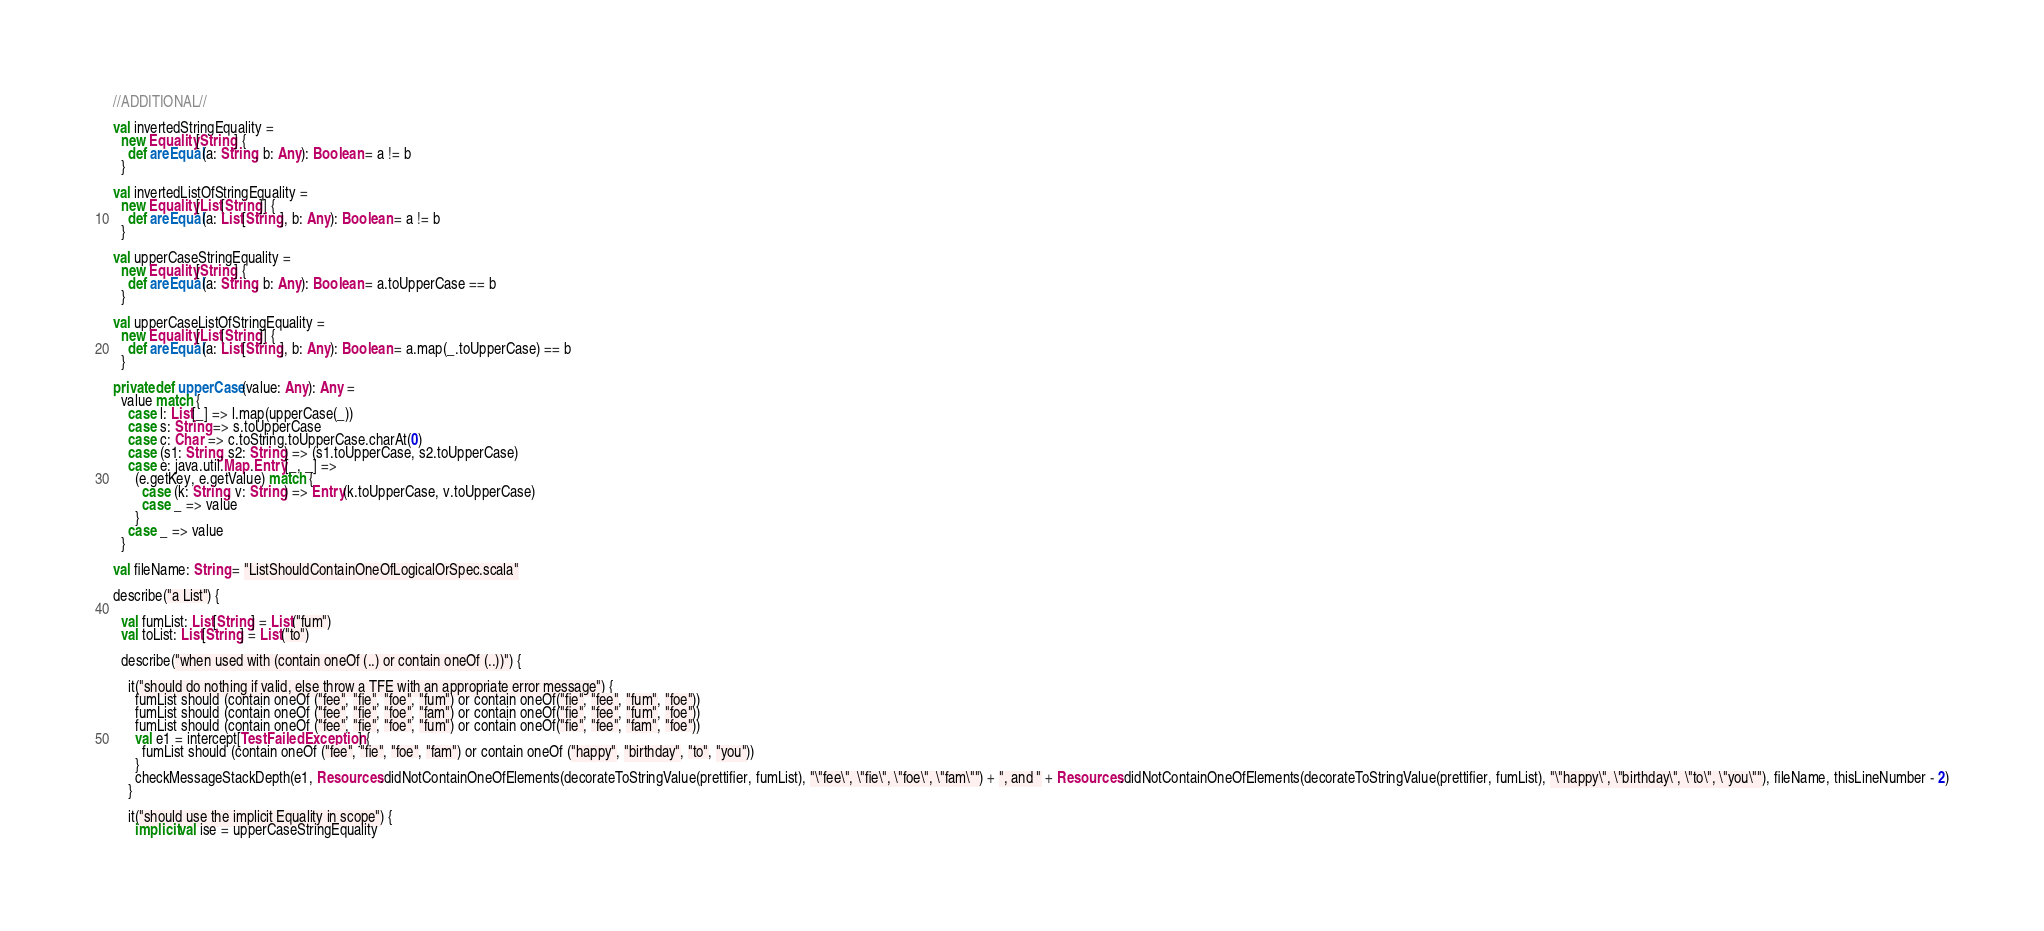<code> <loc_0><loc_0><loc_500><loc_500><_Scala_>  //ADDITIONAL//

  val invertedStringEquality =
    new Equality[String] {
      def areEqual(a: String, b: Any): Boolean = a != b
    }

  val invertedListOfStringEquality =
    new Equality[List[String]] {
      def areEqual(a: List[String], b: Any): Boolean = a != b
    }

  val upperCaseStringEquality =
    new Equality[String] {
      def areEqual(a: String, b: Any): Boolean = a.toUpperCase == b
    }

  val upperCaseListOfStringEquality =
    new Equality[List[String]] {
      def areEqual(a: List[String], b: Any): Boolean = a.map(_.toUpperCase) == b
    }

  private def upperCase(value: Any): Any =
    value match {
      case l: List[_] => l.map(upperCase(_))
      case s: String => s.toUpperCase
      case c: Char => c.toString.toUpperCase.charAt(0)
      case (s1: String, s2: String) => (s1.toUpperCase, s2.toUpperCase)
      case e: java.util.Map.Entry[_, _] =>
        (e.getKey, e.getValue) match {
          case (k: String, v: String) => Entry(k.toUpperCase, v.toUpperCase)
          case _ => value
        }
      case _ => value
    }

  val fileName: String = "ListShouldContainOneOfLogicalOrSpec.scala"

  describe("a List") {

    val fumList: List[String] = List("fum")
    val toList: List[String] = List("to")

    describe("when used with (contain oneOf (..) or contain oneOf (..))") {

      it("should do nothing if valid, else throw a TFE with an appropriate error message") {
        fumList should (contain oneOf ("fee", "fie", "foe", "fum") or contain oneOf("fie", "fee", "fum", "foe"))
        fumList should (contain oneOf ("fee", "fie", "foe", "fam") or contain oneOf("fie", "fee", "fum", "foe"))
        fumList should (contain oneOf ("fee", "fie", "foe", "fum") or contain oneOf("fie", "fee", "fam", "foe"))
        val e1 = intercept[TestFailedException] {
          fumList should (contain oneOf ("fee", "fie", "foe", "fam") or contain oneOf ("happy", "birthday", "to", "you"))
        }
        checkMessageStackDepth(e1, Resources.didNotContainOneOfElements(decorateToStringValue(prettifier, fumList), "\"fee\", \"fie\", \"foe\", \"fam\"") + ", and " + Resources.didNotContainOneOfElements(decorateToStringValue(prettifier, fumList), "\"happy\", \"birthday\", \"to\", \"you\""), fileName, thisLineNumber - 2)
      }

      it("should use the implicit Equality in scope") {
        implicit val ise = upperCaseStringEquality</code> 